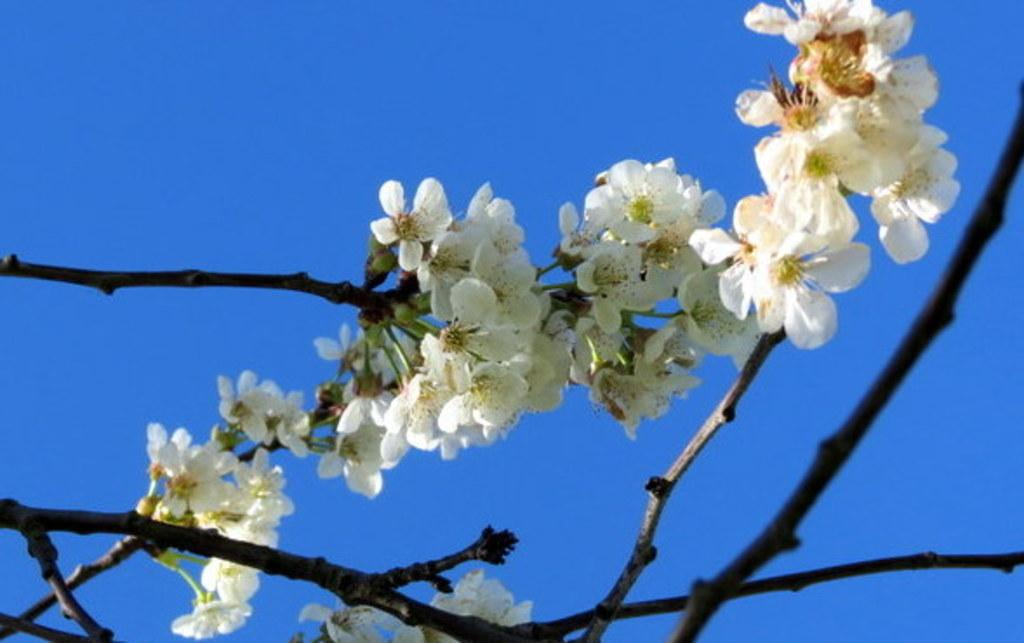What type of plants can be seen in the image? There are flowers in the image. What else is present in the image besides flowers? There are branches in the image. What can be seen in the background of the image? The sky is visible in the background of the image. What type of pan is being used to cook the flowers in the image? There is no pan or cooking activity present in the image; it features flowers and branches. 